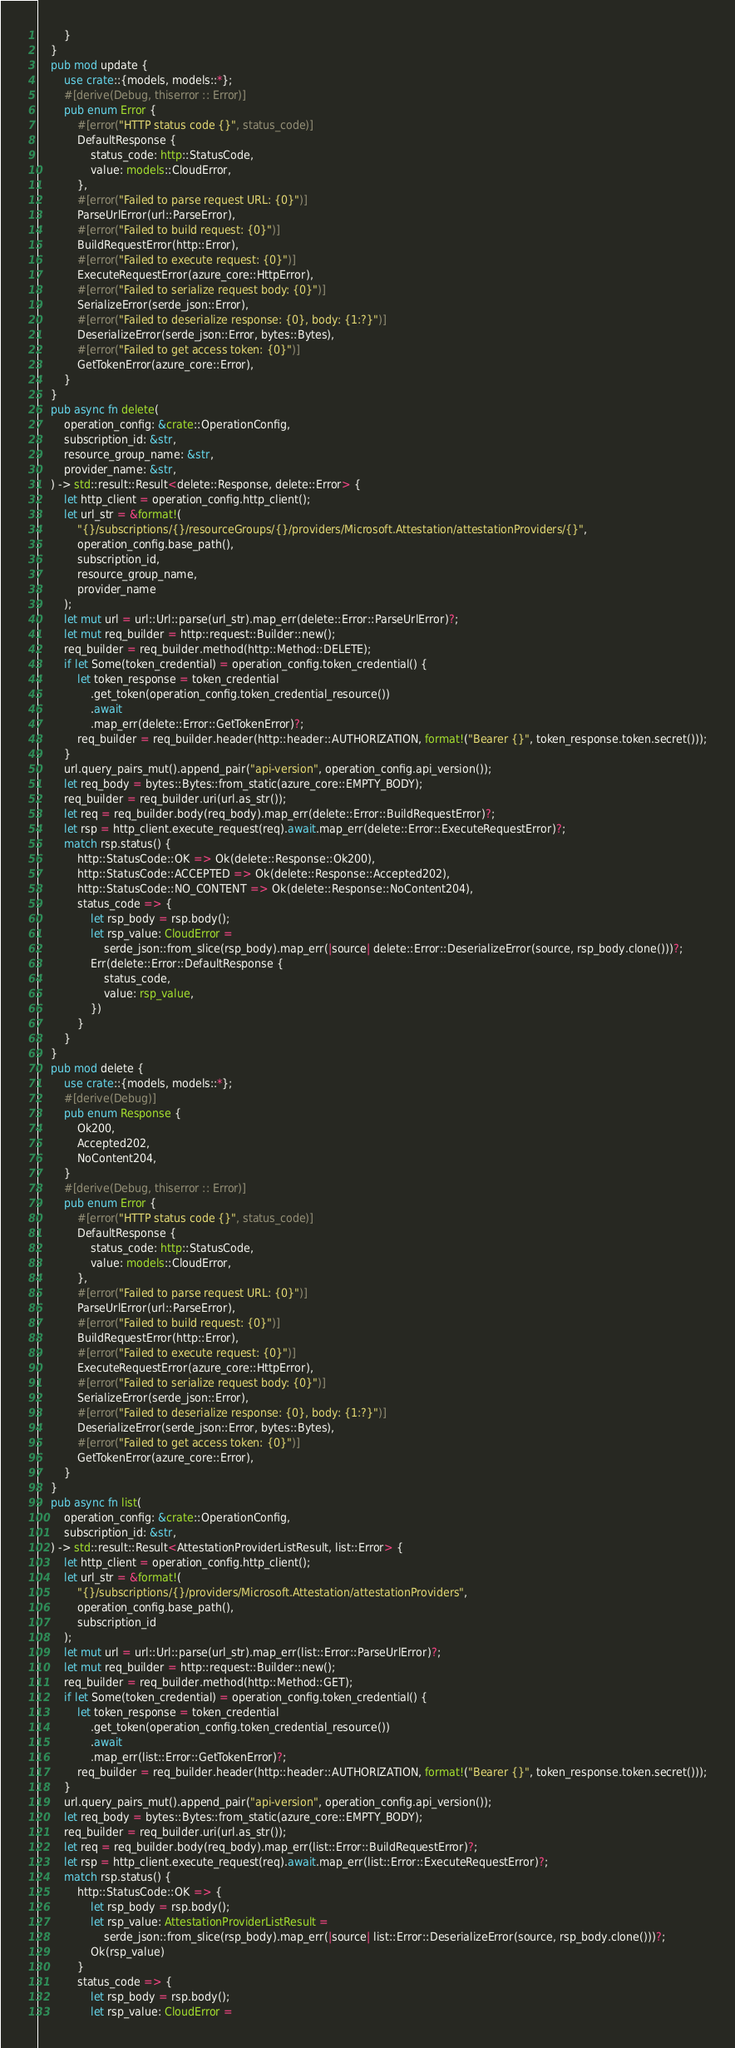Convert code to text. <code><loc_0><loc_0><loc_500><loc_500><_Rust_>        }
    }
    pub mod update {
        use crate::{models, models::*};
        #[derive(Debug, thiserror :: Error)]
        pub enum Error {
            #[error("HTTP status code {}", status_code)]
            DefaultResponse {
                status_code: http::StatusCode,
                value: models::CloudError,
            },
            #[error("Failed to parse request URL: {0}")]
            ParseUrlError(url::ParseError),
            #[error("Failed to build request: {0}")]
            BuildRequestError(http::Error),
            #[error("Failed to execute request: {0}")]
            ExecuteRequestError(azure_core::HttpError),
            #[error("Failed to serialize request body: {0}")]
            SerializeError(serde_json::Error),
            #[error("Failed to deserialize response: {0}, body: {1:?}")]
            DeserializeError(serde_json::Error, bytes::Bytes),
            #[error("Failed to get access token: {0}")]
            GetTokenError(azure_core::Error),
        }
    }
    pub async fn delete(
        operation_config: &crate::OperationConfig,
        subscription_id: &str,
        resource_group_name: &str,
        provider_name: &str,
    ) -> std::result::Result<delete::Response, delete::Error> {
        let http_client = operation_config.http_client();
        let url_str = &format!(
            "{}/subscriptions/{}/resourceGroups/{}/providers/Microsoft.Attestation/attestationProviders/{}",
            operation_config.base_path(),
            subscription_id,
            resource_group_name,
            provider_name
        );
        let mut url = url::Url::parse(url_str).map_err(delete::Error::ParseUrlError)?;
        let mut req_builder = http::request::Builder::new();
        req_builder = req_builder.method(http::Method::DELETE);
        if let Some(token_credential) = operation_config.token_credential() {
            let token_response = token_credential
                .get_token(operation_config.token_credential_resource())
                .await
                .map_err(delete::Error::GetTokenError)?;
            req_builder = req_builder.header(http::header::AUTHORIZATION, format!("Bearer {}", token_response.token.secret()));
        }
        url.query_pairs_mut().append_pair("api-version", operation_config.api_version());
        let req_body = bytes::Bytes::from_static(azure_core::EMPTY_BODY);
        req_builder = req_builder.uri(url.as_str());
        let req = req_builder.body(req_body).map_err(delete::Error::BuildRequestError)?;
        let rsp = http_client.execute_request(req).await.map_err(delete::Error::ExecuteRequestError)?;
        match rsp.status() {
            http::StatusCode::OK => Ok(delete::Response::Ok200),
            http::StatusCode::ACCEPTED => Ok(delete::Response::Accepted202),
            http::StatusCode::NO_CONTENT => Ok(delete::Response::NoContent204),
            status_code => {
                let rsp_body = rsp.body();
                let rsp_value: CloudError =
                    serde_json::from_slice(rsp_body).map_err(|source| delete::Error::DeserializeError(source, rsp_body.clone()))?;
                Err(delete::Error::DefaultResponse {
                    status_code,
                    value: rsp_value,
                })
            }
        }
    }
    pub mod delete {
        use crate::{models, models::*};
        #[derive(Debug)]
        pub enum Response {
            Ok200,
            Accepted202,
            NoContent204,
        }
        #[derive(Debug, thiserror :: Error)]
        pub enum Error {
            #[error("HTTP status code {}", status_code)]
            DefaultResponse {
                status_code: http::StatusCode,
                value: models::CloudError,
            },
            #[error("Failed to parse request URL: {0}")]
            ParseUrlError(url::ParseError),
            #[error("Failed to build request: {0}")]
            BuildRequestError(http::Error),
            #[error("Failed to execute request: {0}")]
            ExecuteRequestError(azure_core::HttpError),
            #[error("Failed to serialize request body: {0}")]
            SerializeError(serde_json::Error),
            #[error("Failed to deserialize response: {0}, body: {1:?}")]
            DeserializeError(serde_json::Error, bytes::Bytes),
            #[error("Failed to get access token: {0}")]
            GetTokenError(azure_core::Error),
        }
    }
    pub async fn list(
        operation_config: &crate::OperationConfig,
        subscription_id: &str,
    ) -> std::result::Result<AttestationProviderListResult, list::Error> {
        let http_client = operation_config.http_client();
        let url_str = &format!(
            "{}/subscriptions/{}/providers/Microsoft.Attestation/attestationProviders",
            operation_config.base_path(),
            subscription_id
        );
        let mut url = url::Url::parse(url_str).map_err(list::Error::ParseUrlError)?;
        let mut req_builder = http::request::Builder::new();
        req_builder = req_builder.method(http::Method::GET);
        if let Some(token_credential) = operation_config.token_credential() {
            let token_response = token_credential
                .get_token(operation_config.token_credential_resource())
                .await
                .map_err(list::Error::GetTokenError)?;
            req_builder = req_builder.header(http::header::AUTHORIZATION, format!("Bearer {}", token_response.token.secret()));
        }
        url.query_pairs_mut().append_pair("api-version", operation_config.api_version());
        let req_body = bytes::Bytes::from_static(azure_core::EMPTY_BODY);
        req_builder = req_builder.uri(url.as_str());
        let req = req_builder.body(req_body).map_err(list::Error::BuildRequestError)?;
        let rsp = http_client.execute_request(req).await.map_err(list::Error::ExecuteRequestError)?;
        match rsp.status() {
            http::StatusCode::OK => {
                let rsp_body = rsp.body();
                let rsp_value: AttestationProviderListResult =
                    serde_json::from_slice(rsp_body).map_err(|source| list::Error::DeserializeError(source, rsp_body.clone()))?;
                Ok(rsp_value)
            }
            status_code => {
                let rsp_body = rsp.body();
                let rsp_value: CloudError =</code> 